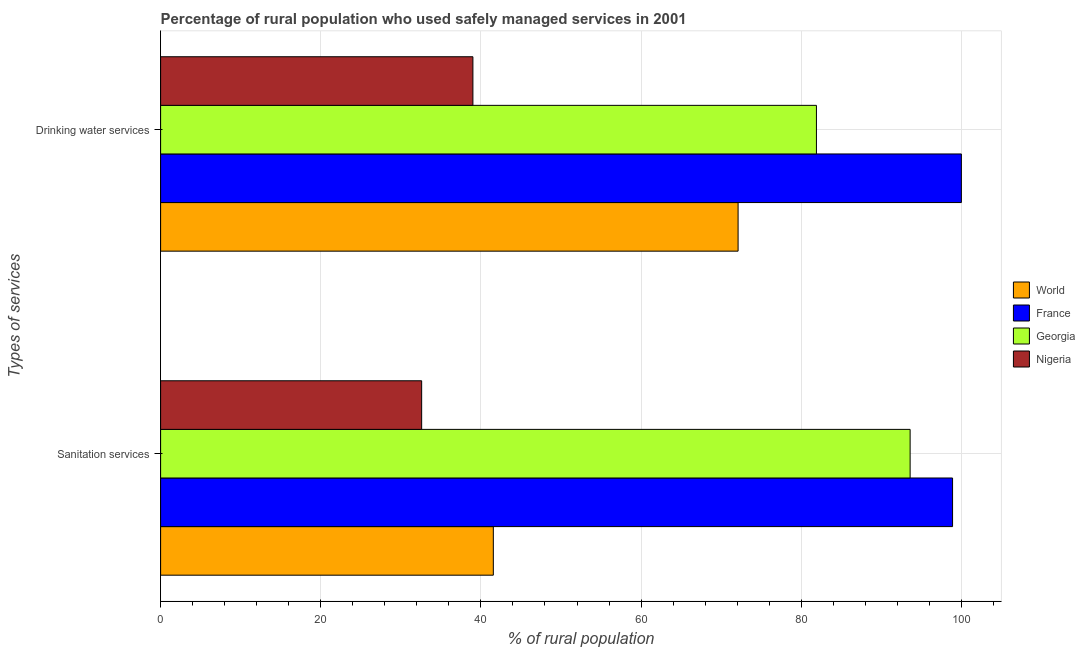How many different coloured bars are there?
Offer a terse response. 4. How many groups of bars are there?
Make the answer very short. 2. Are the number of bars per tick equal to the number of legend labels?
Offer a terse response. Yes. Are the number of bars on each tick of the Y-axis equal?
Offer a very short reply. Yes. How many bars are there on the 1st tick from the top?
Offer a very short reply. 4. How many bars are there on the 1st tick from the bottom?
Provide a short and direct response. 4. What is the label of the 1st group of bars from the top?
Provide a short and direct response. Drinking water services. What is the percentage of rural population who used drinking water services in Georgia?
Your answer should be very brief. 81.9. Across all countries, what is the maximum percentage of rural population who used sanitation services?
Ensure brevity in your answer.  98.9. Across all countries, what is the minimum percentage of rural population who used sanitation services?
Give a very brief answer. 32.6. In which country was the percentage of rural population who used drinking water services maximum?
Make the answer very short. France. In which country was the percentage of rural population who used sanitation services minimum?
Provide a succinct answer. Nigeria. What is the total percentage of rural population who used sanitation services in the graph?
Provide a succinct answer. 266.65. What is the difference between the percentage of rural population who used sanitation services in Georgia and that in France?
Keep it short and to the point. -5.3. What is the difference between the percentage of rural population who used drinking water services in Nigeria and the percentage of rural population who used sanitation services in Georgia?
Provide a short and direct response. -54.6. What is the average percentage of rural population who used drinking water services per country?
Make the answer very short. 73.25. What is the difference between the percentage of rural population who used drinking water services and percentage of rural population who used sanitation services in France?
Your answer should be compact. 1.1. What is the ratio of the percentage of rural population who used drinking water services in Nigeria to that in World?
Your answer should be very brief. 0.54. Is the percentage of rural population who used sanitation services in France less than that in Nigeria?
Your response must be concise. No. What does the 4th bar from the bottom in Sanitation services represents?
Your response must be concise. Nigeria. Are all the bars in the graph horizontal?
Keep it short and to the point. Yes. How many countries are there in the graph?
Keep it short and to the point. 4. What is the difference between two consecutive major ticks on the X-axis?
Your response must be concise. 20. Does the graph contain any zero values?
Ensure brevity in your answer.  No. Does the graph contain grids?
Your answer should be very brief. Yes. How are the legend labels stacked?
Your answer should be very brief. Vertical. What is the title of the graph?
Your answer should be compact. Percentage of rural population who used safely managed services in 2001. Does "St. Lucia" appear as one of the legend labels in the graph?
Your answer should be compact. No. What is the label or title of the X-axis?
Ensure brevity in your answer.  % of rural population. What is the label or title of the Y-axis?
Give a very brief answer. Types of services. What is the % of rural population of World in Sanitation services?
Offer a very short reply. 41.55. What is the % of rural population in France in Sanitation services?
Ensure brevity in your answer.  98.9. What is the % of rural population of Georgia in Sanitation services?
Your answer should be compact. 93.6. What is the % of rural population of Nigeria in Sanitation services?
Make the answer very short. 32.6. What is the % of rural population in World in Drinking water services?
Make the answer very short. 72.12. What is the % of rural population in Georgia in Drinking water services?
Ensure brevity in your answer.  81.9. Across all Types of services, what is the maximum % of rural population of World?
Offer a very short reply. 72.12. Across all Types of services, what is the maximum % of rural population of France?
Keep it short and to the point. 100. Across all Types of services, what is the maximum % of rural population in Georgia?
Provide a short and direct response. 93.6. Across all Types of services, what is the minimum % of rural population of World?
Provide a succinct answer. 41.55. Across all Types of services, what is the minimum % of rural population of France?
Your response must be concise. 98.9. Across all Types of services, what is the minimum % of rural population in Georgia?
Offer a very short reply. 81.9. Across all Types of services, what is the minimum % of rural population of Nigeria?
Ensure brevity in your answer.  32.6. What is the total % of rural population of World in the graph?
Keep it short and to the point. 113.67. What is the total % of rural population of France in the graph?
Keep it short and to the point. 198.9. What is the total % of rural population in Georgia in the graph?
Offer a terse response. 175.5. What is the total % of rural population in Nigeria in the graph?
Offer a very short reply. 71.6. What is the difference between the % of rural population of World in Sanitation services and that in Drinking water services?
Your answer should be compact. -30.57. What is the difference between the % of rural population of France in Sanitation services and that in Drinking water services?
Provide a succinct answer. -1.1. What is the difference between the % of rural population of Georgia in Sanitation services and that in Drinking water services?
Give a very brief answer. 11.7. What is the difference between the % of rural population in World in Sanitation services and the % of rural population in France in Drinking water services?
Offer a terse response. -58.45. What is the difference between the % of rural population of World in Sanitation services and the % of rural population of Georgia in Drinking water services?
Provide a short and direct response. -40.35. What is the difference between the % of rural population of World in Sanitation services and the % of rural population of Nigeria in Drinking water services?
Your answer should be compact. 2.55. What is the difference between the % of rural population in France in Sanitation services and the % of rural population in Georgia in Drinking water services?
Your answer should be compact. 17. What is the difference between the % of rural population in France in Sanitation services and the % of rural population in Nigeria in Drinking water services?
Your answer should be compact. 59.9. What is the difference between the % of rural population of Georgia in Sanitation services and the % of rural population of Nigeria in Drinking water services?
Keep it short and to the point. 54.6. What is the average % of rural population in World per Types of services?
Your answer should be very brief. 56.83. What is the average % of rural population of France per Types of services?
Ensure brevity in your answer.  99.45. What is the average % of rural population of Georgia per Types of services?
Offer a terse response. 87.75. What is the average % of rural population in Nigeria per Types of services?
Offer a very short reply. 35.8. What is the difference between the % of rural population of World and % of rural population of France in Sanitation services?
Give a very brief answer. -57.35. What is the difference between the % of rural population of World and % of rural population of Georgia in Sanitation services?
Keep it short and to the point. -52.05. What is the difference between the % of rural population in World and % of rural population in Nigeria in Sanitation services?
Offer a terse response. 8.95. What is the difference between the % of rural population in France and % of rural population in Georgia in Sanitation services?
Provide a succinct answer. 5.3. What is the difference between the % of rural population of France and % of rural population of Nigeria in Sanitation services?
Keep it short and to the point. 66.3. What is the difference between the % of rural population of World and % of rural population of France in Drinking water services?
Provide a short and direct response. -27.88. What is the difference between the % of rural population in World and % of rural population in Georgia in Drinking water services?
Your answer should be compact. -9.78. What is the difference between the % of rural population of World and % of rural population of Nigeria in Drinking water services?
Offer a terse response. 33.12. What is the difference between the % of rural population in France and % of rural population in Georgia in Drinking water services?
Your answer should be compact. 18.1. What is the difference between the % of rural population of Georgia and % of rural population of Nigeria in Drinking water services?
Give a very brief answer. 42.9. What is the ratio of the % of rural population of World in Sanitation services to that in Drinking water services?
Provide a short and direct response. 0.58. What is the ratio of the % of rural population of Georgia in Sanitation services to that in Drinking water services?
Offer a very short reply. 1.14. What is the ratio of the % of rural population of Nigeria in Sanitation services to that in Drinking water services?
Offer a terse response. 0.84. What is the difference between the highest and the second highest % of rural population in World?
Offer a terse response. 30.57. What is the difference between the highest and the second highest % of rural population in France?
Your answer should be very brief. 1.1. What is the difference between the highest and the second highest % of rural population in Georgia?
Make the answer very short. 11.7. What is the difference between the highest and the second highest % of rural population in Nigeria?
Provide a succinct answer. 6.4. What is the difference between the highest and the lowest % of rural population in World?
Provide a short and direct response. 30.57. What is the difference between the highest and the lowest % of rural population of Nigeria?
Offer a very short reply. 6.4. 